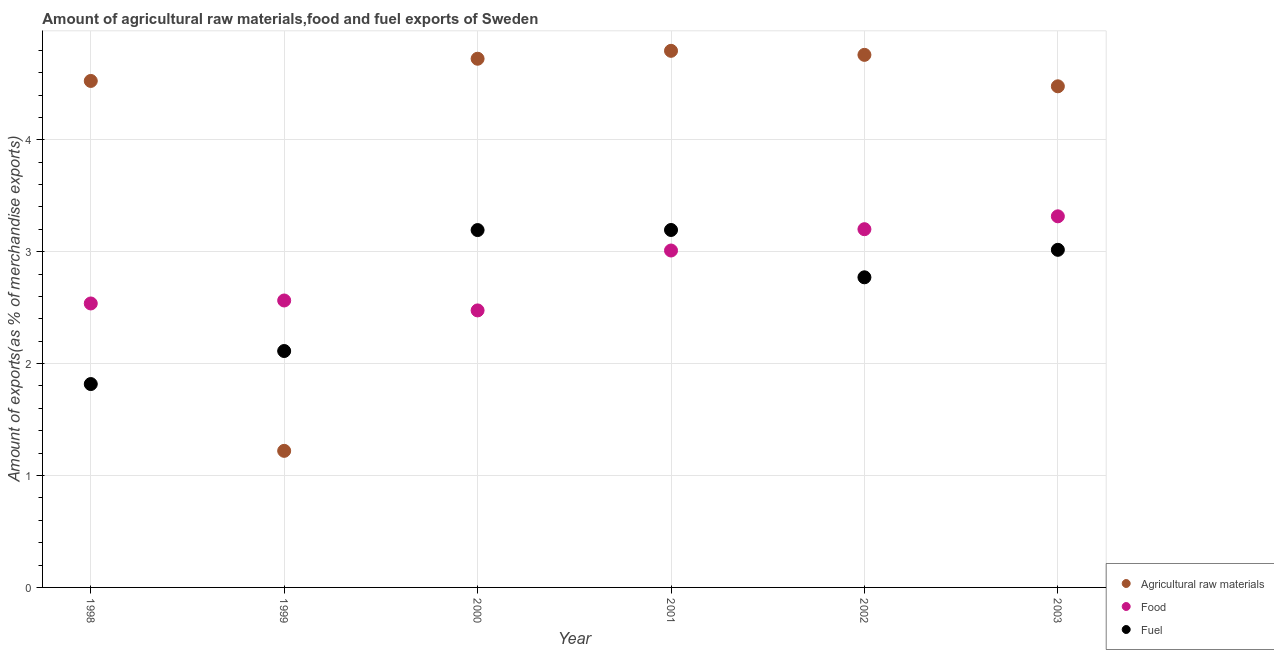How many different coloured dotlines are there?
Your answer should be compact. 3. Is the number of dotlines equal to the number of legend labels?
Give a very brief answer. Yes. What is the percentage of fuel exports in 1998?
Your answer should be compact. 1.82. Across all years, what is the maximum percentage of raw materials exports?
Make the answer very short. 4.8. Across all years, what is the minimum percentage of fuel exports?
Provide a succinct answer. 1.82. In which year was the percentage of raw materials exports maximum?
Provide a short and direct response. 2001. What is the total percentage of raw materials exports in the graph?
Keep it short and to the point. 24.5. What is the difference between the percentage of raw materials exports in 1999 and that in 2001?
Your response must be concise. -3.57. What is the difference between the percentage of fuel exports in 2001 and the percentage of raw materials exports in 2002?
Offer a terse response. -1.56. What is the average percentage of raw materials exports per year?
Offer a very short reply. 4.08. In the year 2003, what is the difference between the percentage of fuel exports and percentage of raw materials exports?
Your answer should be very brief. -1.46. What is the ratio of the percentage of food exports in 2001 to that in 2003?
Keep it short and to the point. 0.91. Is the percentage of raw materials exports in 2002 less than that in 2003?
Your answer should be compact. No. What is the difference between the highest and the second highest percentage of food exports?
Your response must be concise. 0.12. What is the difference between the highest and the lowest percentage of raw materials exports?
Keep it short and to the point. 3.57. Is the sum of the percentage of fuel exports in 1998 and 2000 greater than the maximum percentage of food exports across all years?
Provide a succinct answer. Yes. Is the percentage of food exports strictly greater than the percentage of fuel exports over the years?
Offer a very short reply. No. Is the percentage of fuel exports strictly less than the percentage of food exports over the years?
Provide a succinct answer. No. How many dotlines are there?
Offer a very short reply. 3. What is the difference between two consecutive major ticks on the Y-axis?
Your answer should be compact. 1. Does the graph contain grids?
Give a very brief answer. Yes. Where does the legend appear in the graph?
Offer a terse response. Bottom right. How many legend labels are there?
Your response must be concise. 3. What is the title of the graph?
Offer a terse response. Amount of agricultural raw materials,food and fuel exports of Sweden. What is the label or title of the X-axis?
Provide a short and direct response. Year. What is the label or title of the Y-axis?
Give a very brief answer. Amount of exports(as % of merchandise exports). What is the Amount of exports(as % of merchandise exports) of Agricultural raw materials in 1998?
Ensure brevity in your answer.  4.53. What is the Amount of exports(as % of merchandise exports) in Food in 1998?
Give a very brief answer. 2.54. What is the Amount of exports(as % of merchandise exports) in Fuel in 1998?
Give a very brief answer. 1.82. What is the Amount of exports(as % of merchandise exports) in Agricultural raw materials in 1999?
Your answer should be very brief. 1.22. What is the Amount of exports(as % of merchandise exports) of Food in 1999?
Your response must be concise. 2.56. What is the Amount of exports(as % of merchandise exports) of Fuel in 1999?
Your response must be concise. 2.11. What is the Amount of exports(as % of merchandise exports) of Agricultural raw materials in 2000?
Your answer should be very brief. 4.72. What is the Amount of exports(as % of merchandise exports) of Food in 2000?
Your answer should be very brief. 2.48. What is the Amount of exports(as % of merchandise exports) in Fuel in 2000?
Your answer should be compact. 3.19. What is the Amount of exports(as % of merchandise exports) in Agricultural raw materials in 2001?
Provide a short and direct response. 4.8. What is the Amount of exports(as % of merchandise exports) in Food in 2001?
Provide a short and direct response. 3.01. What is the Amount of exports(as % of merchandise exports) of Fuel in 2001?
Ensure brevity in your answer.  3.19. What is the Amount of exports(as % of merchandise exports) of Agricultural raw materials in 2002?
Your answer should be very brief. 4.76. What is the Amount of exports(as % of merchandise exports) in Food in 2002?
Your response must be concise. 3.2. What is the Amount of exports(as % of merchandise exports) in Fuel in 2002?
Give a very brief answer. 2.77. What is the Amount of exports(as % of merchandise exports) in Agricultural raw materials in 2003?
Offer a very short reply. 4.48. What is the Amount of exports(as % of merchandise exports) of Food in 2003?
Offer a very short reply. 3.32. What is the Amount of exports(as % of merchandise exports) of Fuel in 2003?
Keep it short and to the point. 3.02. Across all years, what is the maximum Amount of exports(as % of merchandise exports) in Agricultural raw materials?
Offer a very short reply. 4.8. Across all years, what is the maximum Amount of exports(as % of merchandise exports) in Food?
Make the answer very short. 3.32. Across all years, what is the maximum Amount of exports(as % of merchandise exports) in Fuel?
Ensure brevity in your answer.  3.19. Across all years, what is the minimum Amount of exports(as % of merchandise exports) in Agricultural raw materials?
Offer a terse response. 1.22. Across all years, what is the minimum Amount of exports(as % of merchandise exports) in Food?
Provide a succinct answer. 2.48. Across all years, what is the minimum Amount of exports(as % of merchandise exports) of Fuel?
Ensure brevity in your answer.  1.82. What is the total Amount of exports(as % of merchandise exports) of Agricultural raw materials in the graph?
Provide a short and direct response. 24.5. What is the total Amount of exports(as % of merchandise exports) in Food in the graph?
Ensure brevity in your answer.  17.11. What is the total Amount of exports(as % of merchandise exports) in Fuel in the graph?
Make the answer very short. 16.11. What is the difference between the Amount of exports(as % of merchandise exports) in Agricultural raw materials in 1998 and that in 1999?
Your response must be concise. 3.31. What is the difference between the Amount of exports(as % of merchandise exports) in Food in 1998 and that in 1999?
Keep it short and to the point. -0.03. What is the difference between the Amount of exports(as % of merchandise exports) of Fuel in 1998 and that in 1999?
Give a very brief answer. -0.3. What is the difference between the Amount of exports(as % of merchandise exports) in Agricultural raw materials in 1998 and that in 2000?
Your answer should be very brief. -0.2. What is the difference between the Amount of exports(as % of merchandise exports) of Food in 1998 and that in 2000?
Provide a succinct answer. 0.06. What is the difference between the Amount of exports(as % of merchandise exports) in Fuel in 1998 and that in 2000?
Give a very brief answer. -1.38. What is the difference between the Amount of exports(as % of merchandise exports) of Agricultural raw materials in 1998 and that in 2001?
Offer a very short reply. -0.27. What is the difference between the Amount of exports(as % of merchandise exports) in Food in 1998 and that in 2001?
Offer a very short reply. -0.47. What is the difference between the Amount of exports(as % of merchandise exports) in Fuel in 1998 and that in 2001?
Provide a short and direct response. -1.38. What is the difference between the Amount of exports(as % of merchandise exports) in Agricultural raw materials in 1998 and that in 2002?
Your response must be concise. -0.23. What is the difference between the Amount of exports(as % of merchandise exports) in Food in 1998 and that in 2002?
Your response must be concise. -0.66. What is the difference between the Amount of exports(as % of merchandise exports) in Fuel in 1998 and that in 2002?
Give a very brief answer. -0.95. What is the difference between the Amount of exports(as % of merchandise exports) of Agricultural raw materials in 1998 and that in 2003?
Offer a terse response. 0.05. What is the difference between the Amount of exports(as % of merchandise exports) in Food in 1998 and that in 2003?
Make the answer very short. -0.78. What is the difference between the Amount of exports(as % of merchandise exports) of Fuel in 1998 and that in 2003?
Your answer should be very brief. -1.2. What is the difference between the Amount of exports(as % of merchandise exports) in Agricultural raw materials in 1999 and that in 2000?
Give a very brief answer. -3.5. What is the difference between the Amount of exports(as % of merchandise exports) of Food in 1999 and that in 2000?
Your response must be concise. 0.09. What is the difference between the Amount of exports(as % of merchandise exports) of Fuel in 1999 and that in 2000?
Provide a succinct answer. -1.08. What is the difference between the Amount of exports(as % of merchandise exports) in Agricultural raw materials in 1999 and that in 2001?
Provide a short and direct response. -3.57. What is the difference between the Amount of exports(as % of merchandise exports) of Food in 1999 and that in 2001?
Offer a terse response. -0.45. What is the difference between the Amount of exports(as % of merchandise exports) of Fuel in 1999 and that in 2001?
Give a very brief answer. -1.08. What is the difference between the Amount of exports(as % of merchandise exports) in Agricultural raw materials in 1999 and that in 2002?
Offer a very short reply. -3.54. What is the difference between the Amount of exports(as % of merchandise exports) of Food in 1999 and that in 2002?
Keep it short and to the point. -0.64. What is the difference between the Amount of exports(as % of merchandise exports) in Fuel in 1999 and that in 2002?
Provide a short and direct response. -0.66. What is the difference between the Amount of exports(as % of merchandise exports) of Agricultural raw materials in 1999 and that in 2003?
Your response must be concise. -3.26. What is the difference between the Amount of exports(as % of merchandise exports) of Food in 1999 and that in 2003?
Provide a short and direct response. -0.75. What is the difference between the Amount of exports(as % of merchandise exports) in Fuel in 1999 and that in 2003?
Your answer should be compact. -0.9. What is the difference between the Amount of exports(as % of merchandise exports) in Agricultural raw materials in 2000 and that in 2001?
Offer a very short reply. -0.07. What is the difference between the Amount of exports(as % of merchandise exports) of Food in 2000 and that in 2001?
Provide a succinct answer. -0.54. What is the difference between the Amount of exports(as % of merchandise exports) in Fuel in 2000 and that in 2001?
Provide a succinct answer. -0. What is the difference between the Amount of exports(as % of merchandise exports) of Agricultural raw materials in 2000 and that in 2002?
Offer a very short reply. -0.03. What is the difference between the Amount of exports(as % of merchandise exports) of Food in 2000 and that in 2002?
Your answer should be compact. -0.73. What is the difference between the Amount of exports(as % of merchandise exports) in Fuel in 2000 and that in 2002?
Keep it short and to the point. 0.42. What is the difference between the Amount of exports(as % of merchandise exports) of Agricultural raw materials in 2000 and that in 2003?
Ensure brevity in your answer.  0.25. What is the difference between the Amount of exports(as % of merchandise exports) of Food in 2000 and that in 2003?
Offer a terse response. -0.84. What is the difference between the Amount of exports(as % of merchandise exports) in Fuel in 2000 and that in 2003?
Your answer should be very brief. 0.18. What is the difference between the Amount of exports(as % of merchandise exports) in Agricultural raw materials in 2001 and that in 2002?
Provide a succinct answer. 0.04. What is the difference between the Amount of exports(as % of merchandise exports) of Food in 2001 and that in 2002?
Your response must be concise. -0.19. What is the difference between the Amount of exports(as % of merchandise exports) of Fuel in 2001 and that in 2002?
Provide a short and direct response. 0.42. What is the difference between the Amount of exports(as % of merchandise exports) in Agricultural raw materials in 2001 and that in 2003?
Offer a terse response. 0.32. What is the difference between the Amount of exports(as % of merchandise exports) of Food in 2001 and that in 2003?
Offer a very short reply. -0.31. What is the difference between the Amount of exports(as % of merchandise exports) in Fuel in 2001 and that in 2003?
Provide a succinct answer. 0.18. What is the difference between the Amount of exports(as % of merchandise exports) of Agricultural raw materials in 2002 and that in 2003?
Provide a succinct answer. 0.28. What is the difference between the Amount of exports(as % of merchandise exports) in Food in 2002 and that in 2003?
Your answer should be very brief. -0.12. What is the difference between the Amount of exports(as % of merchandise exports) of Fuel in 2002 and that in 2003?
Provide a succinct answer. -0.25. What is the difference between the Amount of exports(as % of merchandise exports) in Agricultural raw materials in 1998 and the Amount of exports(as % of merchandise exports) in Food in 1999?
Offer a very short reply. 1.96. What is the difference between the Amount of exports(as % of merchandise exports) of Agricultural raw materials in 1998 and the Amount of exports(as % of merchandise exports) of Fuel in 1999?
Provide a short and direct response. 2.41. What is the difference between the Amount of exports(as % of merchandise exports) of Food in 1998 and the Amount of exports(as % of merchandise exports) of Fuel in 1999?
Ensure brevity in your answer.  0.42. What is the difference between the Amount of exports(as % of merchandise exports) in Agricultural raw materials in 1998 and the Amount of exports(as % of merchandise exports) in Food in 2000?
Offer a terse response. 2.05. What is the difference between the Amount of exports(as % of merchandise exports) in Agricultural raw materials in 1998 and the Amount of exports(as % of merchandise exports) in Fuel in 2000?
Your answer should be compact. 1.33. What is the difference between the Amount of exports(as % of merchandise exports) of Food in 1998 and the Amount of exports(as % of merchandise exports) of Fuel in 2000?
Ensure brevity in your answer.  -0.66. What is the difference between the Amount of exports(as % of merchandise exports) in Agricultural raw materials in 1998 and the Amount of exports(as % of merchandise exports) in Food in 2001?
Keep it short and to the point. 1.52. What is the difference between the Amount of exports(as % of merchandise exports) in Agricultural raw materials in 1998 and the Amount of exports(as % of merchandise exports) in Fuel in 2001?
Give a very brief answer. 1.33. What is the difference between the Amount of exports(as % of merchandise exports) of Food in 1998 and the Amount of exports(as % of merchandise exports) of Fuel in 2001?
Your answer should be compact. -0.66. What is the difference between the Amount of exports(as % of merchandise exports) in Agricultural raw materials in 1998 and the Amount of exports(as % of merchandise exports) in Food in 2002?
Provide a succinct answer. 1.32. What is the difference between the Amount of exports(as % of merchandise exports) in Agricultural raw materials in 1998 and the Amount of exports(as % of merchandise exports) in Fuel in 2002?
Give a very brief answer. 1.75. What is the difference between the Amount of exports(as % of merchandise exports) of Food in 1998 and the Amount of exports(as % of merchandise exports) of Fuel in 2002?
Keep it short and to the point. -0.23. What is the difference between the Amount of exports(as % of merchandise exports) in Agricultural raw materials in 1998 and the Amount of exports(as % of merchandise exports) in Food in 2003?
Provide a succinct answer. 1.21. What is the difference between the Amount of exports(as % of merchandise exports) in Agricultural raw materials in 1998 and the Amount of exports(as % of merchandise exports) in Fuel in 2003?
Give a very brief answer. 1.51. What is the difference between the Amount of exports(as % of merchandise exports) of Food in 1998 and the Amount of exports(as % of merchandise exports) of Fuel in 2003?
Provide a succinct answer. -0.48. What is the difference between the Amount of exports(as % of merchandise exports) in Agricultural raw materials in 1999 and the Amount of exports(as % of merchandise exports) in Food in 2000?
Your response must be concise. -1.25. What is the difference between the Amount of exports(as % of merchandise exports) in Agricultural raw materials in 1999 and the Amount of exports(as % of merchandise exports) in Fuel in 2000?
Provide a succinct answer. -1.97. What is the difference between the Amount of exports(as % of merchandise exports) of Food in 1999 and the Amount of exports(as % of merchandise exports) of Fuel in 2000?
Give a very brief answer. -0.63. What is the difference between the Amount of exports(as % of merchandise exports) of Agricultural raw materials in 1999 and the Amount of exports(as % of merchandise exports) of Food in 2001?
Provide a short and direct response. -1.79. What is the difference between the Amount of exports(as % of merchandise exports) of Agricultural raw materials in 1999 and the Amount of exports(as % of merchandise exports) of Fuel in 2001?
Ensure brevity in your answer.  -1.97. What is the difference between the Amount of exports(as % of merchandise exports) of Food in 1999 and the Amount of exports(as % of merchandise exports) of Fuel in 2001?
Make the answer very short. -0.63. What is the difference between the Amount of exports(as % of merchandise exports) of Agricultural raw materials in 1999 and the Amount of exports(as % of merchandise exports) of Food in 2002?
Provide a short and direct response. -1.98. What is the difference between the Amount of exports(as % of merchandise exports) of Agricultural raw materials in 1999 and the Amount of exports(as % of merchandise exports) of Fuel in 2002?
Give a very brief answer. -1.55. What is the difference between the Amount of exports(as % of merchandise exports) of Food in 1999 and the Amount of exports(as % of merchandise exports) of Fuel in 2002?
Give a very brief answer. -0.21. What is the difference between the Amount of exports(as % of merchandise exports) in Agricultural raw materials in 1999 and the Amount of exports(as % of merchandise exports) in Food in 2003?
Your answer should be compact. -2.1. What is the difference between the Amount of exports(as % of merchandise exports) in Agricultural raw materials in 1999 and the Amount of exports(as % of merchandise exports) in Fuel in 2003?
Ensure brevity in your answer.  -1.8. What is the difference between the Amount of exports(as % of merchandise exports) of Food in 1999 and the Amount of exports(as % of merchandise exports) of Fuel in 2003?
Provide a short and direct response. -0.45. What is the difference between the Amount of exports(as % of merchandise exports) in Agricultural raw materials in 2000 and the Amount of exports(as % of merchandise exports) in Food in 2001?
Keep it short and to the point. 1.71. What is the difference between the Amount of exports(as % of merchandise exports) of Agricultural raw materials in 2000 and the Amount of exports(as % of merchandise exports) of Fuel in 2001?
Offer a very short reply. 1.53. What is the difference between the Amount of exports(as % of merchandise exports) in Food in 2000 and the Amount of exports(as % of merchandise exports) in Fuel in 2001?
Ensure brevity in your answer.  -0.72. What is the difference between the Amount of exports(as % of merchandise exports) of Agricultural raw materials in 2000 and the Amount of exports(as % of merchandise exports) of Food in 2002?
Offer a terse response. 1.52. What is the difference between the Amount of exports(as % of merchandise exports) in Agricultural raw materials in 2000 and the Amount of exports(as % of merchandise exports) in Fuel in 2002?
Offer a very short reply. 1.95. What is the difference between the Amount of exports(as % of merchandise exports) of Food in 2000 and the Amount of exports(as % of merchandise exports) of Fuel in 2002?
Offer a terse response. -0.3. What is the difference between the Amount of exports(as % of merchandise exports) in Agricultural raw materials in 2000 and the Amount of exports(as % of merchandise exports) in Food in 2003?
Ensure brevity in your answer.  1.41. What is the difference between the Amount of exports(as % of merchandise exports) of Agricultural raw materials in 2000 and the Amount of exports(as % of merchandise exports) of Fuel in 2003?
Offer a very short reply. 1.71. What is the difference between the Amount of exports(as % of merchandise exports) of Food in 2000 and the Amount of exports(as % of merchandise exports) of Fuel in 2003?
Your answer should be very brief. -0.54. What is the difference between the Amount of exports(as % of merchandise exports) in Agricultural raw materials in 2001 and the Amount of exports(as % of merchandise exports) in Food in 2002?
Your answer should be compact. 1.59. What is the difference between the Amount of exports(as % of merchandise exports) in Agricultural raw materials in 2001 and the Amount of exports(as % of merchandise exports) in Fuel in 2002?
Offer a very short reply. 2.02. What is the difference between the Amount of exports(as % of merchandise exports) of Food in 2001 and the Amount of exports(as % of merchandise exports) of Fuel in 2002?
Make the answer very short. 0.24. What is the difference between the Amount of exports(as % of merchandise exports) in Agricultural raw materials in 2001 and the Amount of exports(as % of merchandise exports) in Food in 2003?
Offer a very short reply. 1.48. What is the difference between the Amount of exports(as % of merchandise exports) of Agricultural raw materials in 2001 and the Amount of exports(as % of merchandise exports) of Fuel in 2003?
Make the answer very short. 1.78. What is the difference between the Amount of exports(as % of merchandise exports) of Food in 2001 and the Amount of exports(as % of merchandise exports) of Fuel in 2003?
Offer a terse response. -0.01. What is the difference between the Amount of exports(as % of merchandise exports) in Agricultural raw materials in 2002 and the Amount of exports(as % of merchandise exports) in Food in 2003?
Your response must be concise. 1.44. What is the difference between the Amount of exports(as % of merchandise exports) in Agricultural raw materials in 2002 and the Amount of exports(as % of merchandise exports) in Fuel in 2003?
Your answer should be very brief. 1.74. What is the difference between the Amount of exports(as % of merchandise exports) of Food in 2002 and the Amount of exports(as % of merchandise exports) of Fuel in 2003?
Ensure brevity in your answer.  0.18. What is the average Amount of exports(as % of merchandise exports) of Agricultural raw materials per year?
Your response must be concise. 4.08. What is the average Amount of exports(as % of merchandise exports) in Food per year?
Provide a short and direct response. 2.85. What is the average Amount of exports(as % of merchandise exports) of Fuel per year?
Offer a terse response. 2.68. In the year 1998, what is the difference between the Amount of exports(as % of merchandise exports) of Agricultural raw materials and Amount of exports(as % of merchandise exports) of Food?
Your answer should be compact. 1.99. In the year 1998, what is the difference between the Amount of exports(as % of merchandise exports) of Agricultural raw materials and Amount of exports(as % of merchandise exports) of Fuel?
Keep it short and to the point. 2.71. In the year 1998, what is the difference between the Amount of exports(as % of merchandise exports) of Food and Amount of exports(as % of merchandise exports) of Fuel?
Keep it short and to the point. 0.72. In the year 1999, what is the difference between the Amount of exports(as % of merchandise exports) in Agricultural raw materials and Amount of exports(as % of merchandise exports) in Food?
Your answer should be compact. -1.34. In the year 1999, what is the difference between the Amount of exports(as % of merchandise exports) in Agricultural raw materials and Amount of exports(as % of merchandise exports) in Fuel?
Give a very brief answer. -0.89. In the year 1999, what is the difference between the Amount of exports(as % of merchandise exports) in Food and Amount of exports(as % of merchandise exports) in Fuel?
Your answer should be very brief. 0.45. In the year 2000, what is the difference between the Amount of exports(as % of merchandise exports) in Agricultural raw materials and Amount of exports(as % of merchandise exports) in Food?
Provide a succinct answer. 2.25. In the year 2000, what is the difference between the Amount of exports(as % of merchandise exports) of Agricultural raw materials and Amount of exports(as % of merchandise exports) of Fuel?
Give a very brief answer. 1.53. In the year 2000, what is the difference between the Amount of exports(as % of merchandise exports) of Food and Amount of exports(as % of merchandise exports) of Fuel?
Give a very brief answer. -0.72. In the year 2001, what is the difference between the Amount of exports(as % of merchandise exports) of Agricultural raw materials and Amount of exports(as % of merchandise exports) of Food?
Give a very brief answer. 1.78. In the year 2001, what is the difference between the Amount of exports(as % of merchandise exports) of Agricultural raw materials and Amount of exports(as % of merchandise exports) of Fuel?
Provide a short and direct response. 1.6. In the year 2001, what is the difference between the Amount of exports(as % of merchandise exports) of Food and Amount of exports(as % of merchandise exports) of Fuel?
Offer a terse response. -0.18. In the year 2002, what is the difference between the Amount of exports(as % of merchandise exports) of Agricultural raw materials and Amount of exports(as % of merchandise exports) of Food?
Keep it short and to the point. 1.56. In the year 2002, what is the difference between the Amount of exports(as % of merchandise exports) in Agricultural raw materials and Amount of exports(as % of merchandise exports) in Fuel?
Your response must be concise. 1.99. In the year 2002, what is the difference between the Amount of exports(as % of merchandise exports) in Food and Amount of exports(as % of merchandise exports) in Fuel?
Ensure brevity in your answer.  0.43. In the year 2003, what is the difference between the Amount of exports(as % of merchandise exports) of Agricultural raw materials and Amount of exports(as % of merchandise exports) of Food?
Keep it short and to the point. 1.16. In the year 2003, what is the difference between the Amount of exports(as % of merchandise exports) of Agricultural raw materials and Amount of exports(as % of merchandise exports) of Fuel?
Provide a succinct answer. 1.46. In the year 2003, what is the difference between the Amount of exports(as % of merchandise exports) in Food and Amount of exports(as % of merchandise exports) in Fuel?
Provide a short and direct response. 0.3. What is the ratio of the Amount of exports(as % of merchandise exports) of Agricultural raw materials in 1998 to that in 1999?
Give a very brief answer. 3.71. What is the ratio of the Amount of exports(as % of merchandise exports) in Fuel in 1998 to that in 1999?
Ensure brevity in your answer.  0.86. What is the ratio of the Amount of exports(as % of merchandise exports) in Agricultural raw materials in 1998 to that in 2000?
Give a very brief answer. 0.96. What is the ratio of the Amount of exports(as % of merchandise exports) of Food in 1998 to that in 2000?
Give a very brief answer. 1.03. What is the ratio of the Amount of exports(as % of merchandise exports) of Fuel in 1998 to that in 2000?
Provide a short and direct response. 0.57. What is the ratio of the Amount of exports(as % of merchandise exports) in Agricultural raw materials in 1998 to that in 2001?
Your response must be concise. 0.94. What is the ratio of the Amount of exports(as % of merchandise exports) in Food in 1998 to that in 2001?
Offer a terse response. 0.84. What is the ratio of the Amount of exports(as % of merchandise exports) in Fuel in 1998 to that in 2001?
Keep it short and to the point. 0.57. What is the ratio of the Amount of exports(as % of merchandise exports) of Agricultural raw materials in 1998 to that in 2002?
Keep it short and to the point. 0.95. What is the ratio of the Amount of exports(as % of merchandise exports) in Food in 1998 to that in 2002?
Provide a succinct answer. 0.79. What is the ratio of the Amount of exports(as % of merchandise exports) of Fuel in 1998 to that in 2002?
Provide a short and direct response. 0.66. What is the ratio of the Amount of exports(as % of merchandise exports) in Agricultural raw materials in 1998 to that in 2003?
Provide a short and direct response. 1.01. What is the ratio of the Amount of exports(as % of merchandise exports) of Food in 1998 to that in 2003?
Give a very brief answer. 0.77. What is the ratio of the Amount of exports(as % of merchandise exports) in Fuel in 1998 to that in 2003?
Your answer should be very brief. 0.6. What is the ratio of the Amount of exports(as % of merchandise exports) of Agricultural raw materials in 1999 to that in 2000?
Your answer should be very brief. 0.26. What is the ratio of the Amount of exports(as % of merchandise exports) of Food in 1999 to that in 2000?
Give a very brief answer. 1.04. What is the ratio of the Amount of exports(as % of merchandise exports) in Fuel in 1999 to that in 2000?
Your answer should be compact. 0.66. What is the ratio of the Amount of exports(as % of merchandise exports) of Agricultural raw materials in 1999 to that in 2001?
Ensure brevity in your answer.  0.25. What is the ratio of the Amount of exports(as % of merchandise exports) of Food in 1999 to that in 2001?
Your answer should be very brief. 0.85. What is the ratio of the Amount of exports(as % of merchandise exports) of Fuel in 1999 to that in 2001?
Ensure brevity in your answer.  0.66. What is the ratio of the Amount of exports(as % of merchandise exports) in Agricultural raw materials in 1999 to that in 2002?
Your response must be concise. 0.26. What is the ratio of the Amount of exports(as % of merchandise exports) of Food in 1999 to that in 2002?
Provide a succinct answer. 0.8. What is the ratio of the Amount of exports(as % of merchandise exports) of Fuel in 1999 to that in 2002?
Offer a very short reply. 0.76. What is the ratio of the Amount of exports(as % of merchandise exports) of Agricultural raw materials in 1999 to that in 2003?
Give a very brief answer. 0.27. What is the ratio of the Amount of exports(as % of merchandise exports) in Food in 1999 to that in 2003?
Offer a very short reply. 0.77. What is the ratio of the Amount of exports(as % of merchandise exports) of Fuel in 1999 to that in 2003?
Offer a terse response. 0.7. What is the ratio of the Amount of exports(as % of merchandise exports) of Food in 2000 to that in 2001?
Provide a short and direct response. 0.82. What is the ratio of the Amount of exports(as % of merchandise exports) in Food in 2000 to that in 2002?
Offer a terse response. 0.77. What is the ratio of the Amount of exports(as % of merchandise exports) in Fuel in 2000 to that in 2002?
Your answer should be very brief. 1.15. What is the ratio of the Amount of exports(as % of merchandise exports) of Agricultural raw materials in 2000 to that in 2003?
Your response must be concise. 1.05. What is the ratio of the Amount of exports(as % of merchandise exports) in Food in 2000 to that in 2003?
Keep it short and to the point. 0.75. What is the ratio of the Amount of exports(as % of merchandise exports) in Fuel in 2000 to that in 2003?
Ensure brevity in your answer.  1.06. What is the ratio of the Amount of exports(as % of merchandise exports) in Agricultural raw materials in 2001 to that in 2002?
Make the answer very short. 1.01. What is the ratio of the Amount of exports(as % of merchandise exports) of Food in 2001 to that in 2002?
Provide a short and direct response. 0.94. What is the ratio of the Amount of exports(as % of merchandise exports) of Fuel in 2001 to that in 2002?
Offer a terse response. 1.15. What is the ratio of the Amount of exports(as % of merchandise exports) of Agricultural raw materials in 2001 to that in 2003?
Ensure brevity in your answer.  1.07. What is the ratio of the Amount of exports(as % of merchandise exports) in Food in 2001 to that in 2003?
Your response must be concise. 0.91. What is the ratio of the Amount of exports(as % of merchandise exports) of Fuel in 2001 to that in 2003?
Make the answer very short. 1.06. What is the ratio of the Amount of exports(as % of merchandise exports) in Agricultural raw materials in 2002 to that in 2003?
Keep it short and to the point. 1.06. What is the ratio of the Amount of exports(as % of merchandise exports) of Food in 2002 to that in 2003?
Provide a succinct answer. 0.97. What is the ratio of the Amount of exports(as % of merchandise exports) of Fuel in 2002 to that in 2003?
Provide a succinct answer. 0.92. What is the difference between the highest and the second highest Amount of exports(as % of merchandise exports) in Agricultural raw materials?
Offer a very short reply. 0.04. What is the difference between the highest and the second highest Amount of exports(as % of merchandise exports) of Food?
Provide a succinct answer. 0.12. What is the difference between the highest and the second highest Amount of exports(as % of merchandise exports) in Fuel?
Provide a short and direct response. 0. What is the difference between the highest and the lowest Amount of exports(as % of merchandise exports) of Agricultural raw materials?
Keep it short and to the point. 3.57. What is the difference between the highest and the lowest Amount of exports(as % of merchandise exports) of Food?
Make the answer very short. 0.84. What is the difference between the highest and the lowest Amount of exports(as % of merchandise exports) of Fuel?
Offer a terse response. 1.38. 